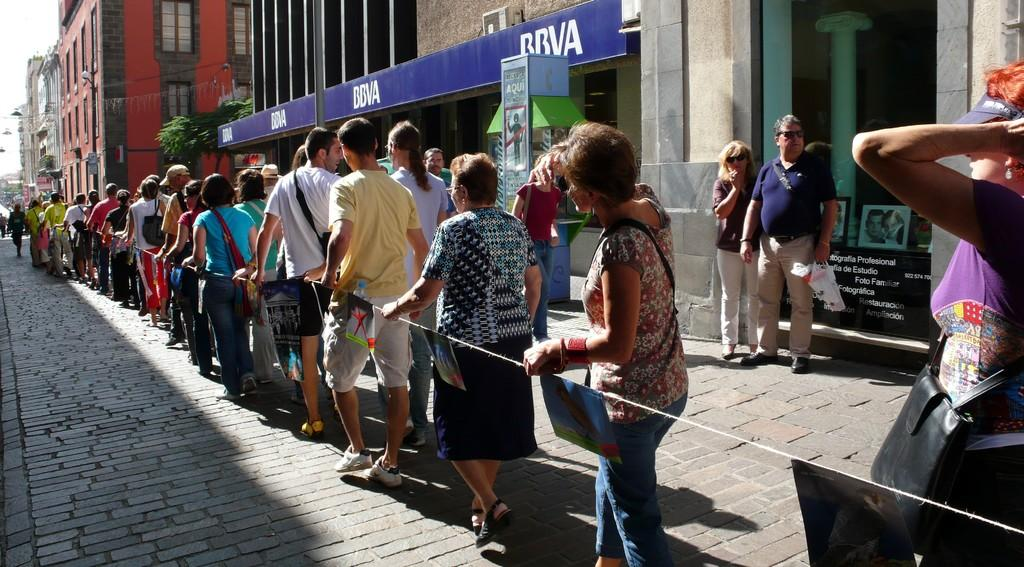Who or what can be seen in the image? There are people in the image. What is the purpose of the posts and rope in the image? The posts and rope in the image are likely used for hanging or supporting something, such as a clothesline or a hammock. What type of structures are visible in the image? There are buildings in the image. What type of vegetation is present in the image? Leaves are present in the image. What is attached to the wall in the image? There is a poster in the image. What can be seen in the background of the image? The sky is visible in the background of the image. What type of oil is being used to lubricate the office in the image? There is no mention of an office or oil in the image; it features people, posts and rope, buildings, leaves, a poster, and the sky. 